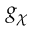<formula> <loc_0><loc_0><loc_500><loc_500>g _ { \chi }</formula> 